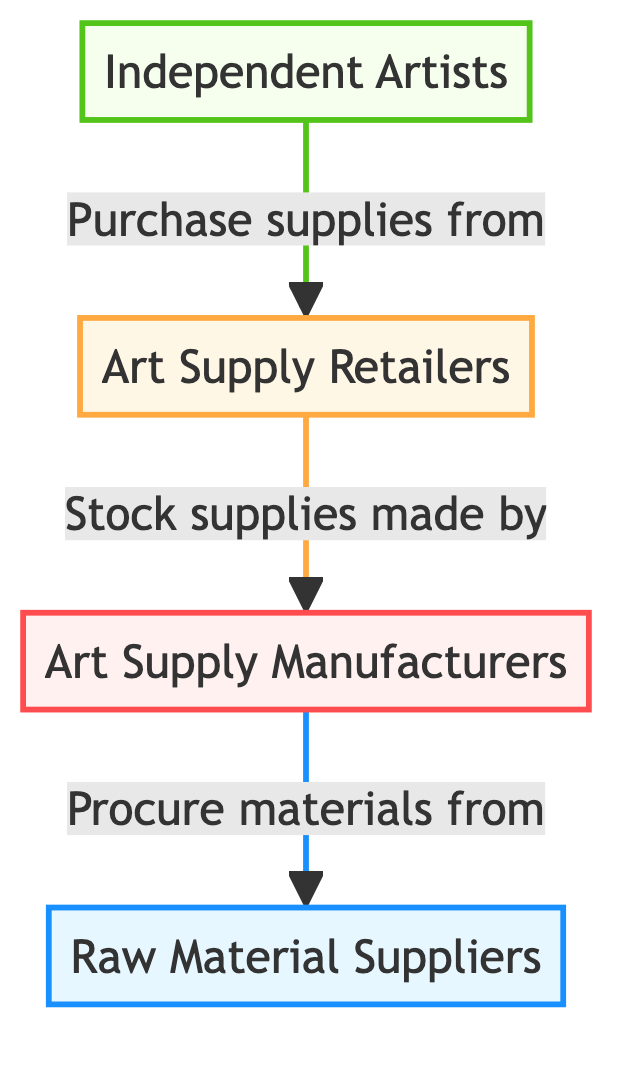What are the main roles represented in the diagram? The diagram shows four main roles: Raw Material Suppliers, Art Supply Manufacturers, Art Supply Retailers, and Independent Artists. These roles indicate the flow of materials and supplies in the art supplies market.
Answer: Raw Material Suppliers, Art Supply Manufacturers, Art Supply Retailers, Independent Artists Which node represents the prey in the food chain? In the diagram, Independent Artists are represented as the prey. They are the final recipients of supplies within the flow, relying on the other nodes for their materials.
Answer: Independent Artists How many edges are there in the diagram? There are three edges in total, connecting the nodes from one to another: Raw Material Suppliers to Art Supply Manufacturers, Art Supply Manufacturers to Art Supply Retailers, and Art Supply Retailers to Independent Artists.
Answer: Three What do Independent Artists purchase from Art Supply Retailers? Independent Artists purchase supplies from Art Supply Retailers, which indicate the flow of products that the artists acquire to create their works.
Answer: Supplies Which group procures materials from Raw Material Suppliers? Art Supply Manufacturers procure materials from Raw Material Suppliers. This indicates their reliance on raw materials to produce final art supplies for the market.
Answer: Art Supply Manufacturers What type of relationship exists between Art Supply Retailers and Independent Artists? The relationship is one of transaction; Independent Artists purchase supplies from Art Supply Retailers, creating a direct buyer-seller interaction.
Answer: Transaction Which node is considered the predator in this food chain? Art Supply Manufacturers are considered the predator in this diagram as they transform raw materials into finished products and are positioned above the retailers and independent artists in the supply hierarchy.
Answer: Art Supply Manufacturers What role does Art Supply Retailers play in the overall dynamic? Art Supply Retailers serve as intermediaries in the supply chain, stocking supplies made by Art Supply Manufacturers and selling them to Independent Artists.
Answer: Intermediaries 